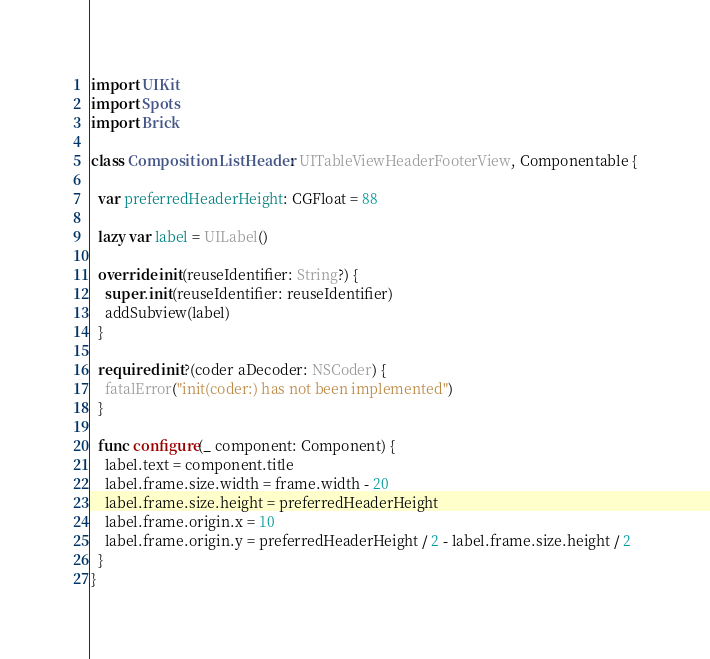Convert code to text. <code><loc_0><loc_0><loc_500><loc_500><_Swift_>import UIKit
import Spots
import Brick

class CompositionListHeader: UITableViewHeaderFooterView, Componentable {

  var preferredHeaderHeight: CGFloat = 88

  lazy var label = UILabel()

  override init(reuseIdentifier: String?) {
    super.init(reuseIdentifier: reuseIdentifier)
    addSubview(label)
  }
  
  required init?(coder aDecoder: NSCoder) {
    fatalError("init(coder:) has not been implemented")
  }

  func configure(_ component: Component) {
    label.text = component.title
    label.frame.size.width = frame.width - 20
    label.frame.size.height = preferredHeaderHeight
    label.frame.origin.x = 10
    label.frame.origin.y = preferredHeaderHeight / 2 - label.frame.size.height / 2
  }
}
</code> 